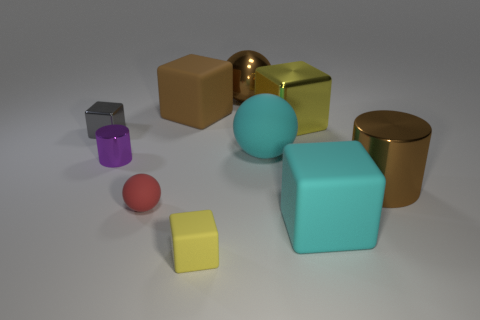Subtract all brown blocks. How many blocks are left? 4 Subtract all cyan cubes. How many cubes are left? 4 Subtract 1 blocks. How many blocks are left? 4 Subtract all red blocks. Subtract all blue cylinders. How many blocks are left? 5 Subtract all spheres. How many objects are left? 7 Subtract 0 gray spheres. How many objects are left? 10 Subtract all big metallic cubes. Subtract all red matte objects. How many objects are left? 8 Add 6 small matte blocks. How many small matte blocks are left? 7 Add 8 large spheres. How many large spheres exist? 10 